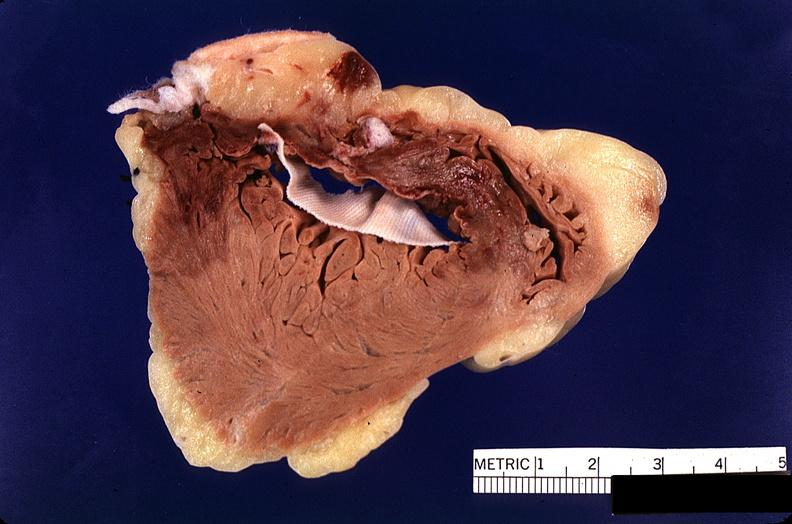where is this?
Answer the question using a single word or phrase. Heart 